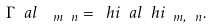<formula> <loc_0><loc_0><loc_500><loc_500>\Gamma ^ { \ } a l _ { \ \ m \ n } = \ h { i } ^ { \ } a l \ h { i } _ { \ m , \ n } .</formula> 